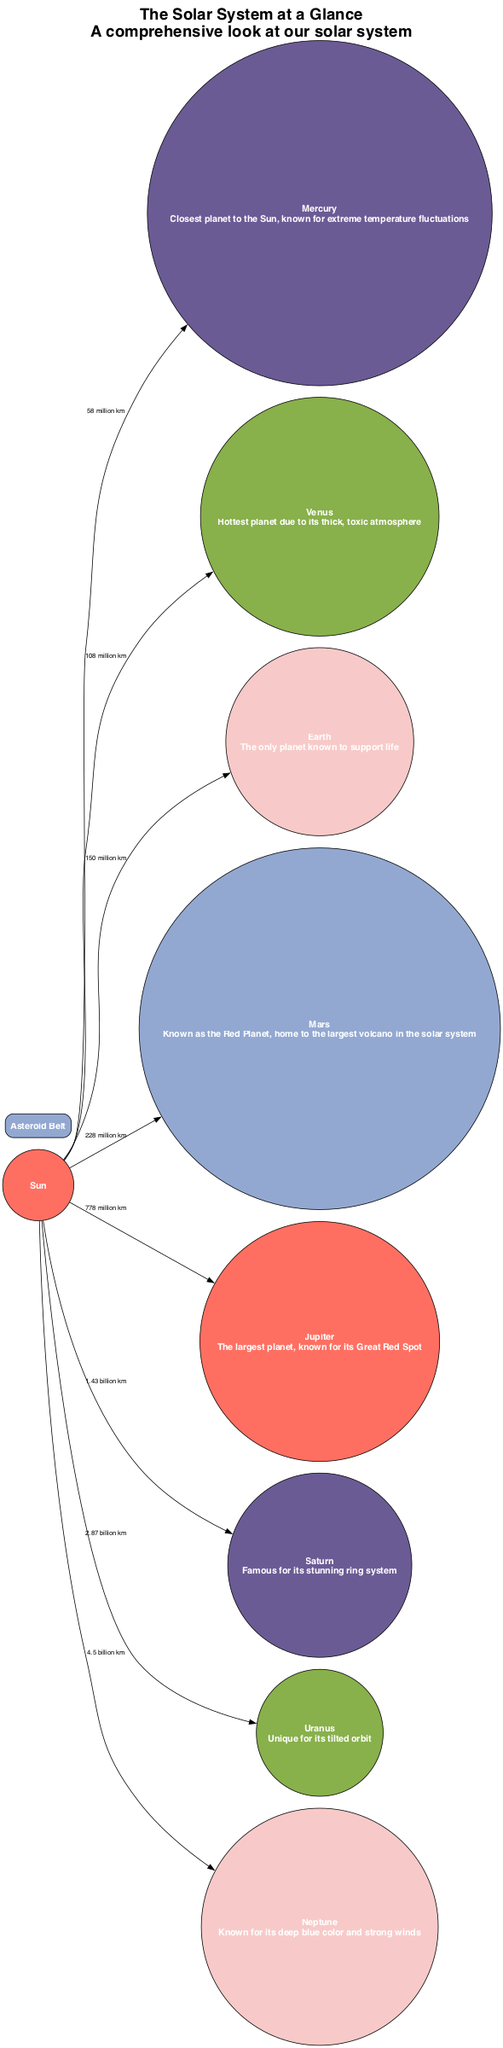What is the distance from the Sun to Mars? The edge connection from the Sun to Mars shows the distance as 228 million km. Thus, the answer is taken directly from this description.
Answer: 228 million km Which planet is known as the Red Planet? The description associated with Mars indicates it is known as the Red Planet. Therefore, the answer comes directly from the label of the planet.
Answer: Mars How many planets are there in the solar system diagram? By counting all the nodes listed under planets (Mercury, Venus, Earth, Mars, Jupiter, Saturn, Uranus, Neptune), we find there are a total of 8. Hence, the answer is derived by counting those specific nodes.
Answer: 8 What is the main characteristic of Jupiter depicted in the diagram? The diagram describes Jupiter as the largest planet, known for its Great Red Spot, which is a specific characteristic presented next to its node.
Answer: Largest planet, known for its Great Red Spot Which planet is furthest from the Sun? By reviewing the edges and distances from the Sun, Neptune is listed as the farthest at 4.5 billion km, making it the correct answer. The answer is derived from comparing the distances listed.
Answer: Neptune What separates Mars from Jupiter in the solar system? The diagram indicates the Asteroid Belt is the region located between Mars and Jupiter. Thus, the answer is acquired directly from the relationship between those two nodes.
Answer: Asteroid Belt What color represents Venus in the diagram? Venus is associated with a color, which can be inferred from the color scheme used in the nodes; Venus corresponds to the second color in the list, which is #6B5B95. Therefore, the color description leads us to the answer.
Answer: #6B5B95 What is unique about Uranus according to the diagram? The description for Uranus notes that it has a unique tilted orbit, which distinguishes it among the planets shown. Thus, the answer can be found in its defining characteristic.
Answer: Unique for its tilted orbit How many edges are connected to the Sun? Counting the edges connected to the Sun with the various planets listed, we find there are a total of 8 edges reaching from the Sun to each planet. The answer is derived by listing these connections.
Answer: 8 